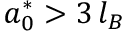<formula> <loc_0><loc_0><loc_500><loc_500>a _ { 0 } ^ { * } > 3 \, l _ { B }</formula> 